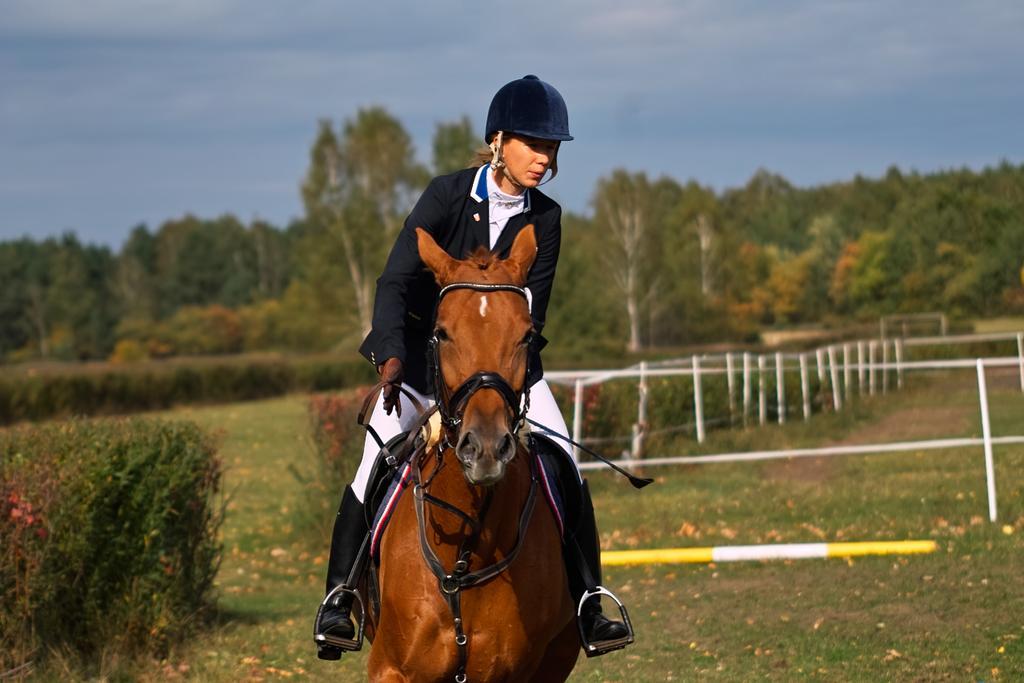Describe this image in one or two sentences. In this picture there is a girl wearing blue color coat and helmet riding a brown color horse. Behind there is a white color fencing grill and many trees. 